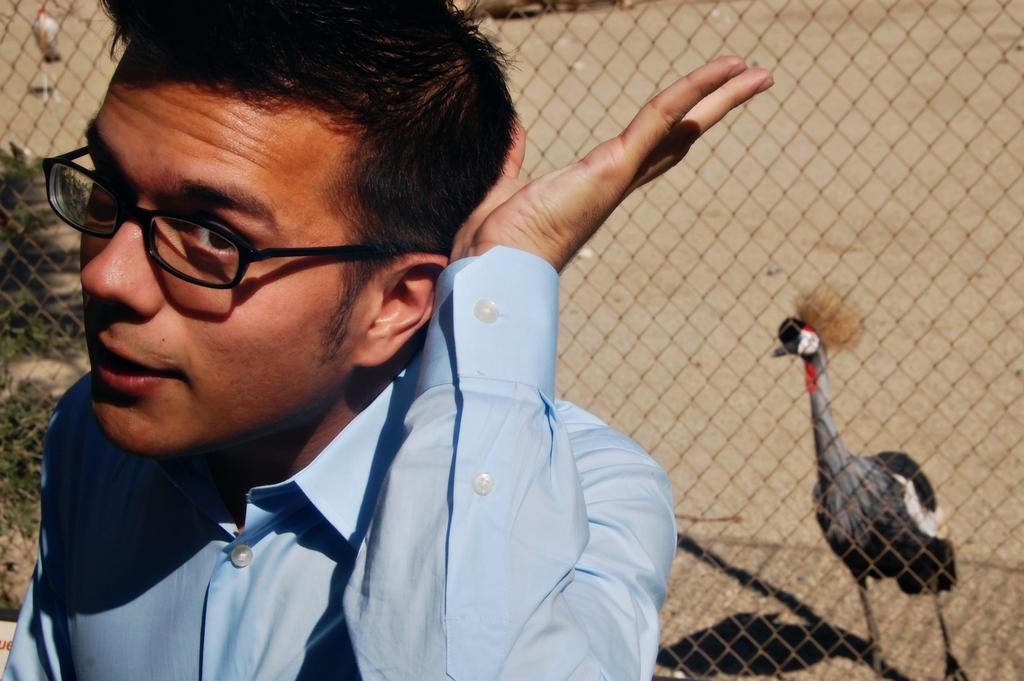Please provide a concise description of this image. In this image we can see a person, behind to him, there are birds, plants, and the fence. 